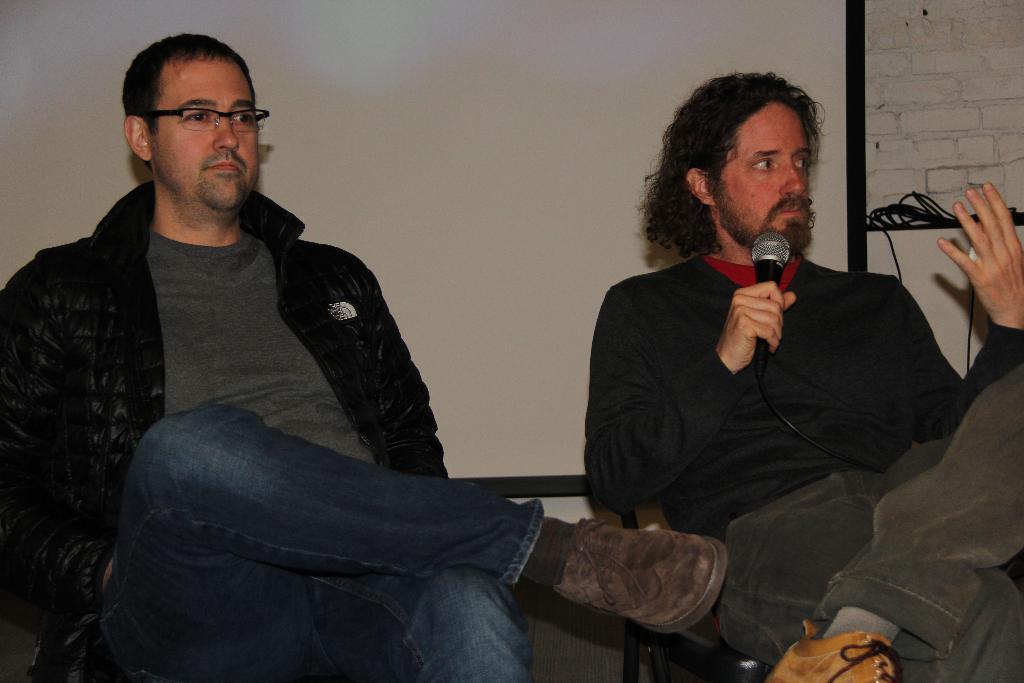How would you summarize this image in a sentence or two? In this image there are persons sitting and on the right side there is a man sitting and holding a mic and there are wires. In the background there is a board which is white in colour and there is a wall which is white in colour. 